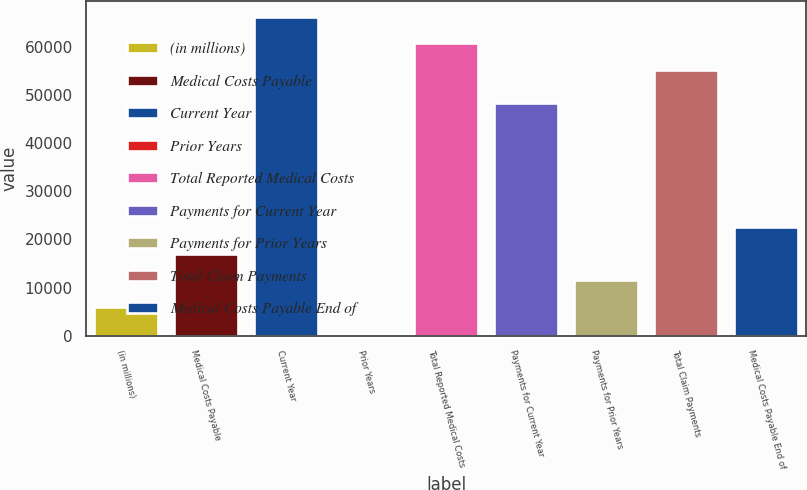Convert chart. <chart><loc_0><loc_0><loc_500><loc_500><bar_chart><fcel>(in millions)<fcel>Medical Costs Payable<fcel>Current Year<fcel>Prior Years<fcel>Total Reported Medical Costs<fcel>Payments for Current Year<fcel>Payments for Prior Years<fcel>Total Claim Payments<fcel>Medical Costs Payable End of<nl><fcel>5963.5<fcel>17050.5<fcel>66267<fcel>420<fcel>60723.5<fcel>48240<fcel>11507<fcel>55180<fcel>22594<nl></chart> 